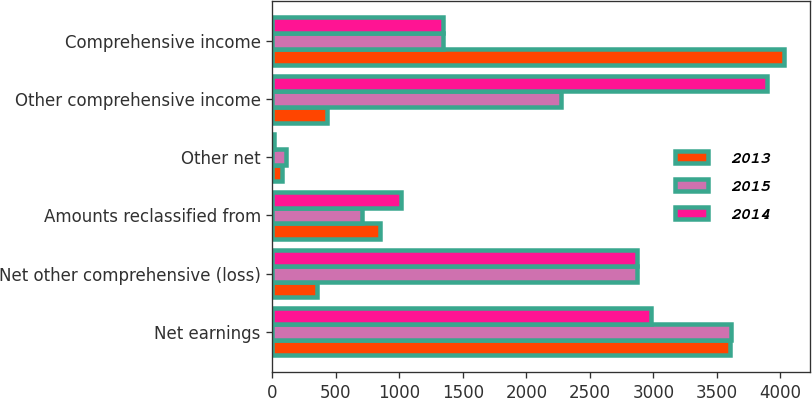Convert chart. <chart><loc_0><loc_0><loc_500><loc_500><stacked_bar_chart><ecel><fcel>Net earnings<fcel>Net other comprehensive (loss)<fcel>Amounts reclassified from<fcel>Other net<fcel>Other comprehensive income<fcel>Comprehensive income<nl><fcel>2013<fcel>3605<fcel>351<fcel>850<fcel>73<fcel>426<fcel>4031<nl><fcel>2015<fcel>3614<fcel>2870<fcel>706<fcel>105<fcel>2269<fcel>1345<nl><fcel>2014<fcel>2981<fcel>2868<fcel>1015<fcel>9<fcel>3892<fcel>1345<nl></chart> 